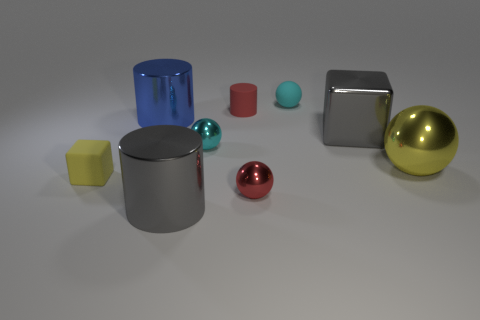Which objects in the image appear to have a metallic reflective surface? The objects with metallic reflective surfaces are the silver cylinder on the left, the silver cube towards the center-right, and the gold sphere on the right. These surfaces reflect the environment and light, giving them a distinctive lustrous appearance. 